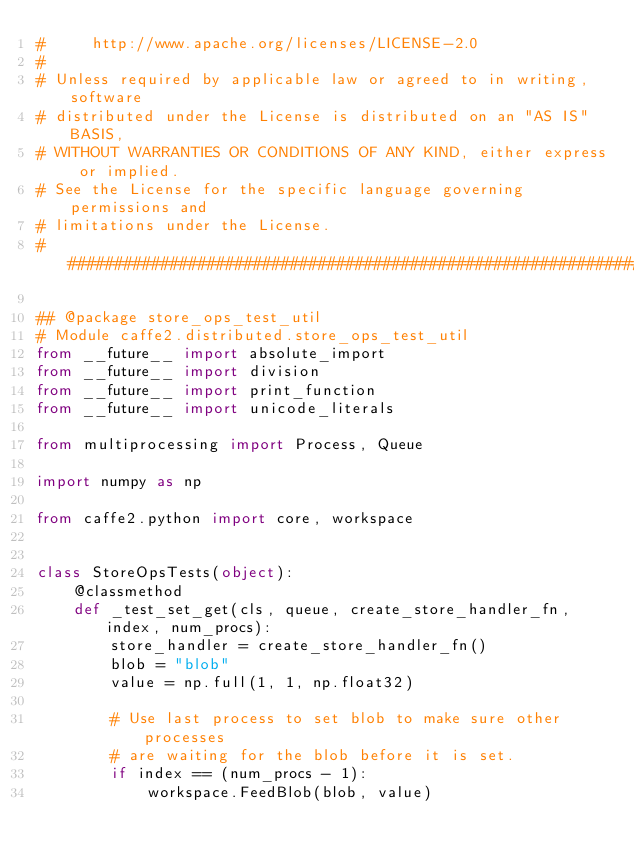Convert code to text. <code><loc_0><loc_0><loc_500><loc_500><_Python_>#     http://www.apache.org/licenses/LICENSE-2.0
#
# Unless required by applicable law or agreed to in writing, software
# distributed under the License is distributed on an "AS IS" BASIS,
# WITHOUT WARRANTIES OR CONDITIONS OF ANY KIND, either express or implied.
# See the License for the specific language governing permissions and
# limitations under the License.
##############################################################################

## @package store_ops_test_util
# Module caffe2.distributed.store_ops_test_util
from __future__ import absolute_import
from __future__ import division
from __future__ import print_function
from __future__ import unicode_literals

from multiprocessing import Process, Queue

import numpy as np

from caffe2.python import core, workspace


class StoreOpsTests(object):
    @classmethod
    def _test_set_get(cls, queue, create_store_handler_fn, index, num_procs):
        store_handler = create_store_handler_fn()
        blob = "blob"
        value = np.full(1, 1, np.float32)

        # Use last process to set blob to make sure other processes
        # are waiting for the blob before it is set.
        if index == (num_procs - 1):
            workspace.FeedBlob(blob, value)</code> 